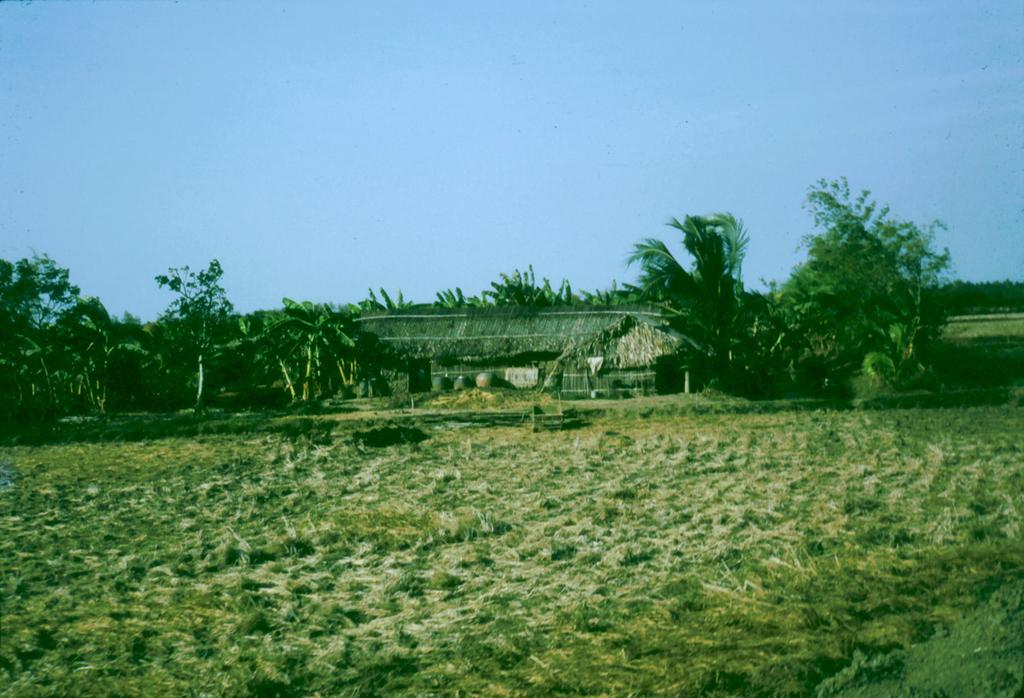What type of vegetation can be seen in the image? There are trees in the image. What type of structure is present in the image? There is a house in the image. What is covering the ground in the image? There is grass on the ground in the image. What color is the sky in the image? The sky is blue in the image. What type of hair can be seen on the trees in the image? There is no hair present on the trees in the image; they are covered with leaves or branches. What type of prose is being written on the grass in the image? There is no prose being written on the grass in the image; it is covered with grass. 